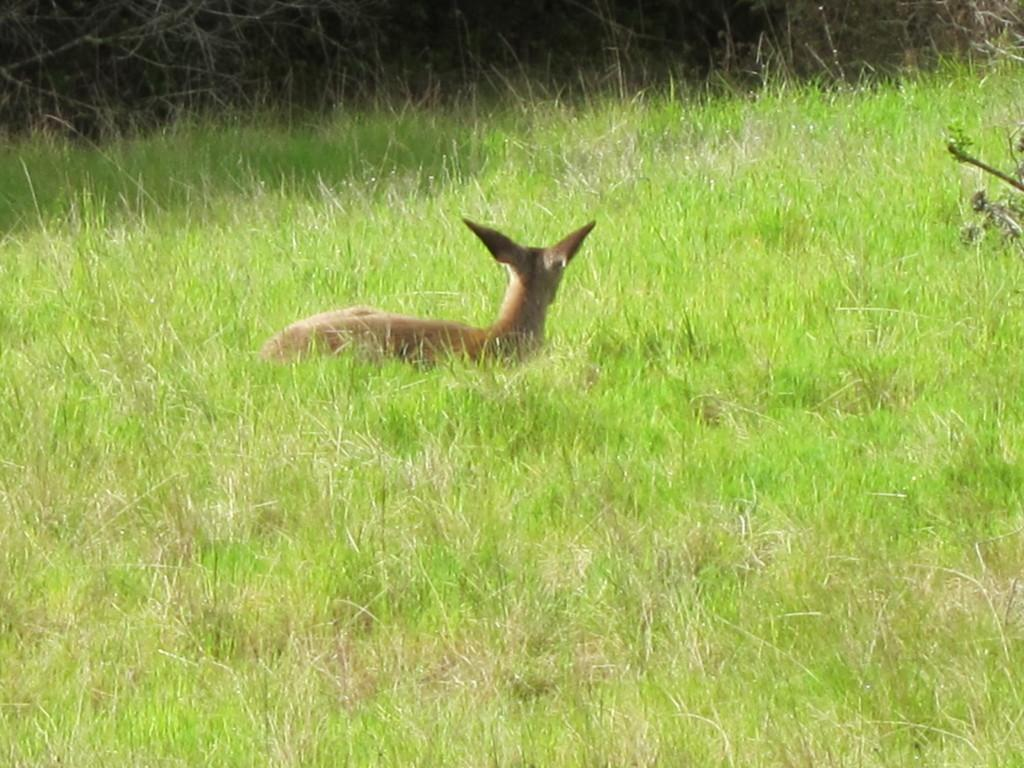What type of creature is present in the image? There is an animal in the image. Can you describe the environment in which the animal is situated? The animal is sitting in green color grass. How many cherries are being attacked by the animal in the image? There are no cherries present in the image, nor is there any indication of an attack. 